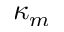Convert formula to latex. <formula><loc_0><loc_0><loc_500><loc_500>\kappa _ { m }</formula> 